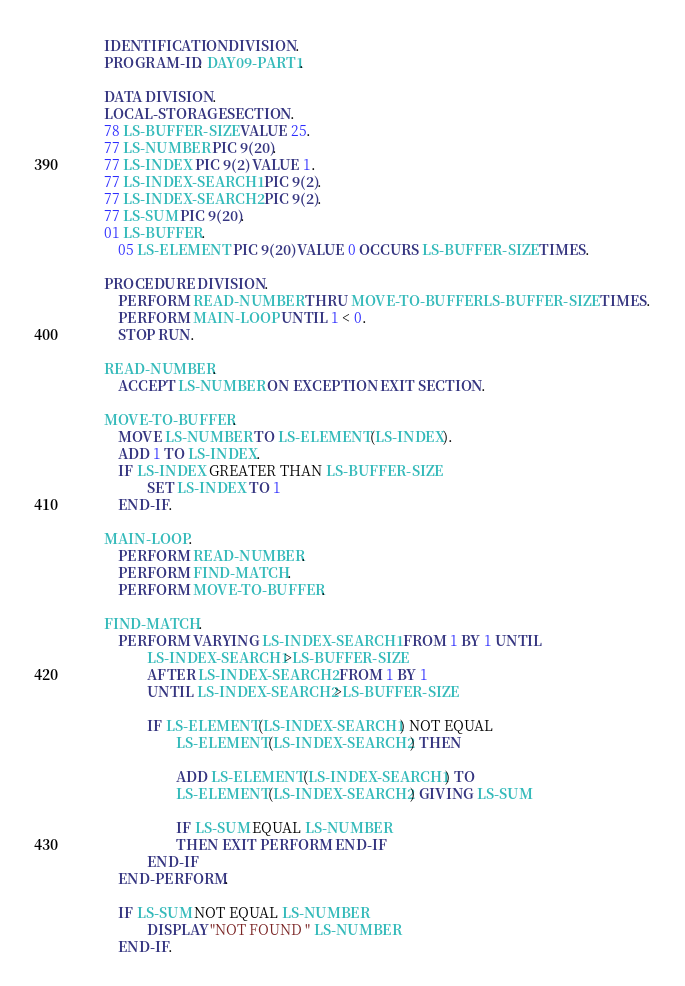<code> <loc_0><loc_0><loc_500><loc_500><_COBOL_>       IDENTIFICATION DIVISION.
       PROGRAM-ID. DAY09-PART1.

       DATA DIVISION.
       LOCAL-STORAGE SECTION.
       78 LS-BUFFER-SIZE VALUE 25.
       77 LS-NUMBER PIC 9(20).
       77 LS-INDEX PIC 9(2) VALUE 1.
       77 LS-INDEX-SEARCH1 PIC 9(2).
       77 LS-INDEX-SEARCH2 PIC 9(2).
       77 LS-SUM PIC 9(20).
       01 LS-BUFFER.
           05 LS-ELEMENT PIC 9(20) VALUE 0 OCCURS LS-BUFFER-SIZE TIMES.

       PROCEDURE DIVISION.
           PERFORM READ-NUMBER THRU MOVE-TO-BUFFER LS-BUFFER-SIZE TIMES.
           PERFORM MAIN-LOOP UNTIL 1 < 0.
           STOP RUN.

       READ-NUMBER.
           ACCEPT LS-NUMBER ON EXCEPTION EXIT SECTION.

       MOVE-TO-BUFFER.
           MOVE LS-NUMBER TO LS-ELEMENT(LS-INDEX).
           ADD 1 TO LS-INDEX.
           IF LS-INDEX GREATER THAN LS-BUFFER-SIZE
                   SET LS-INDEX TO 1
           END-IF.

       MAIN-LOOP.
           PERFORM READ-NUMBER.
           PERFORM FIND-MATCH.
           PERFORM MOVE-TO-BUFFER.

       FIND-MATCH.
           PERFORM VARYING LS-INDEX-SEARCH1 FROM 1 BY 1 UNTIL
                   LS-INDEX-SEARCH1>LS-BUFFER-SIZE
                   AFTER LS-INDEX-SEARCH2 FROM 1 BY 1
                   UNTIL LS-INDEX-SEARCH2>LS-BUFFER-SIZE

                   IF LS-ELEMENT(LS-INDEX-SEARCH1) NOT EQUAL
                           LS-ELEMENT(LS-INDEX-SEARCH2) THEN

                           ADD LS-ELEMENT(LS-INDEX-SEARCH1) TO
                           LS-ELEMENT(LS-INDEX-SEARCH2) GIVING LS-SUM

                           IF LS-SUM EQUAL LS-NUMBER
                           THEN EXIT PERFORM END-IF
                   END-IF
           END-PERFORM.

           IF LS-SUM NOT EQUAL LS-NUMBER
                   DISPLAY "NOT FOUND " LS-NUMBER
           END-IF.
</code> 